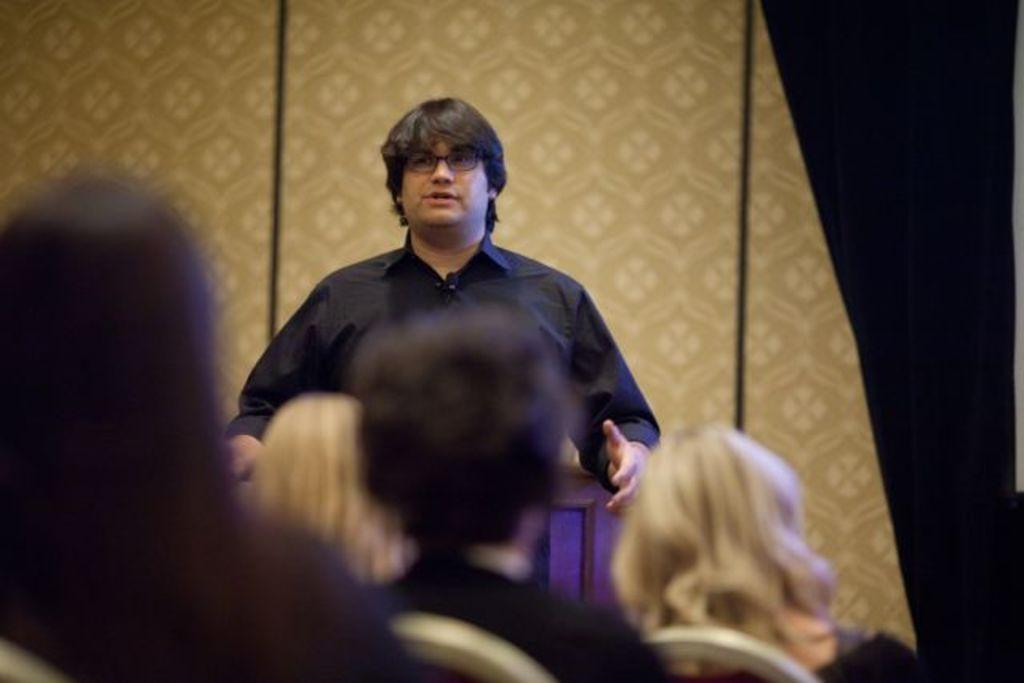What is the main action of the person in the image? The person in the image is standing and talking. How are the other people in the image positioned? There is a group of people sitting on chairs in the foreground of the image. What can be seen in the background of the image? There appears to be a wall in the background of the image. What type of science experiment is being conducted in the image? There is no science experiment present in the image; it features a person standing and talking with a group of people sitting on chairs. 